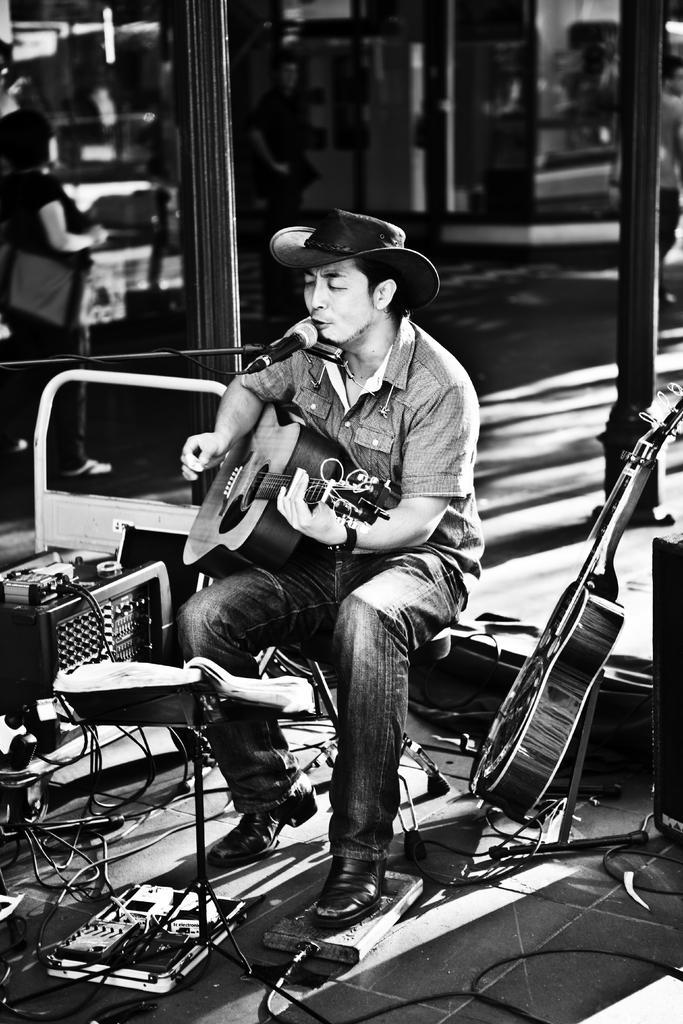Describe this image in one or two sentences. There is a man sitting on a chair holding a guitar wearing a cap singing in a microphone behind him there are so many musical instruments. 